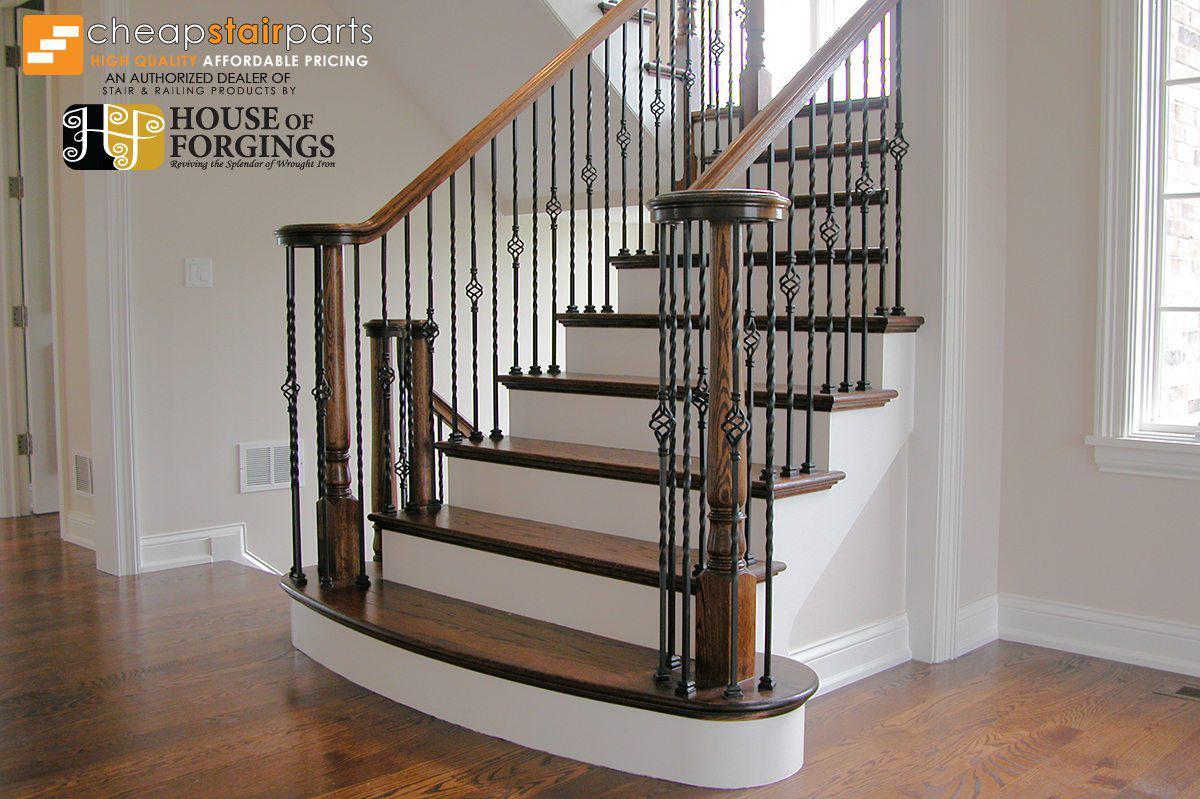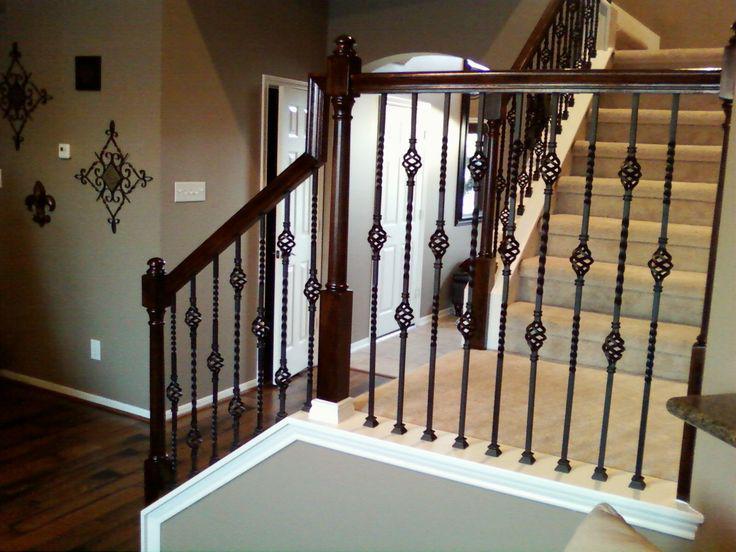The first image is the image on the left, the second image is the image on the right. Examine the images to the left and right. Is the description "The right image shows a curving staircase with brown steps and white baseboards, a curving brown rail, and black wrought iron bars." accurate? Answer yes or no. No. The first image is the image on the left, the second image is the image on the right. Analyze the images presented: Is the assertion "In at least one image there is  a set of stairs point left forward with the bottom step longer than the rest." valid? Answer yes or no. Yes. 